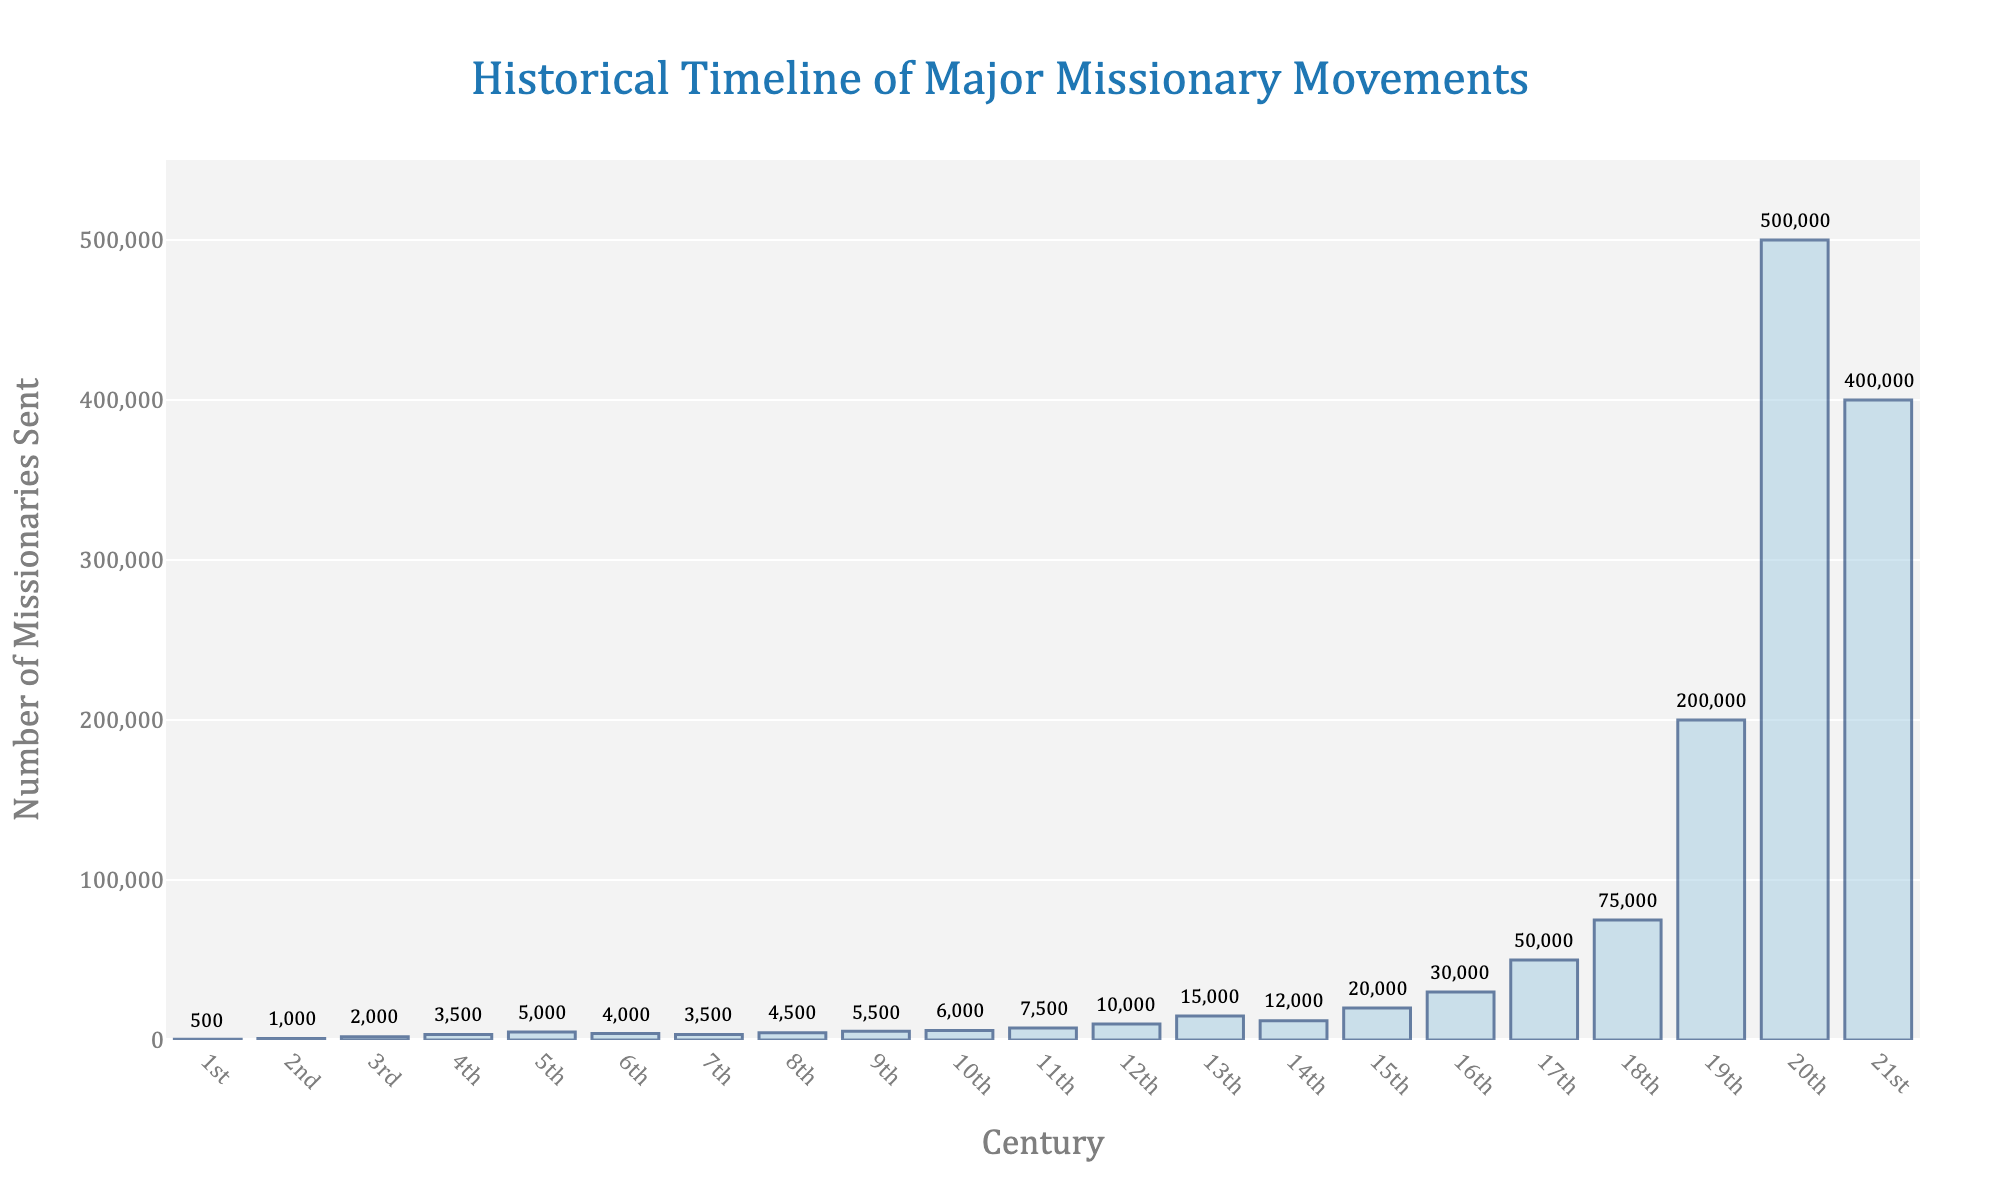What is the century with the highest number of missionaries sent? Observe the bar with the greatest height. The 20th century has the highest number, reaching 500,000 missionaries.
Answer: 20th century Which century had more missionaries sent, the 14th or the 15th century? Compare the heights of the bars for the 14th and 15th centuries. The 15th century has a taller bar at 20,000 compared to 12,000.
Answer: 15th century What is the total number of missionaries sent from the 1st to the 5th century? Sum the values for the 1st, 2nd, 3rd, 4th, and 5th centuries: 500 + 1000 + 2000 + 3500 + 5000 = 12,000.
Answer: 12,000 How does the number of missionaries sent in the 18th century compare to those in the 19th century? The bar for the 19th century is taller at 200,000 while the 18th century is at 75,000, indicating the 19th century had significantly more.
Answer: 19th century What is the average number of missionaries sent per century from the 1st to the 10th century? Add the numbers from the 1st to the 10th centuries and divide by 10: (500 + 1000 + 2000 + 3500 + 5000 + 4000 + 3500 + 4500 + 5500 + 6000) / 10 = 35,500 / 10 = 3,550.
Answer: 3,550 Which century saw a greater increase in the number of missionaries sent, the 12th to the 13th or the 16th to the 17th century? Calculate the difference for each pair: 13th-12th century: 15,000 - 10,000 = 5,000; 17th-16th century: 50,000 - 30,000 = 20,000. The increase from the 16th to the 17th century is greater.
Answer: 16th to 17th century What is the percentage increase in the number of missionaries sent from the 17th century to the 18th century? Calculate the percentage increase: ((75,000 - 50,000) / 50,000) * 100 = 50%.
Answer: 50% How many centuries saw fewer than 10,000 missionaries sent? Identify the bars with height less than 10,000: 1st, 2nd, 3rd, 4th, 5th, 6th, 7th, 8th, 9th, 10th, and 11th centuries which adds up to 11.
Answer: 11 Which century experienced the steepest drop in the number of missionaries sent from the previous century? Compare the differences between subsequent centuries and identify the largest decline: the 21st century fell from 500,000 to 400,000, a drop of 100,000.
Answer: 21st century 